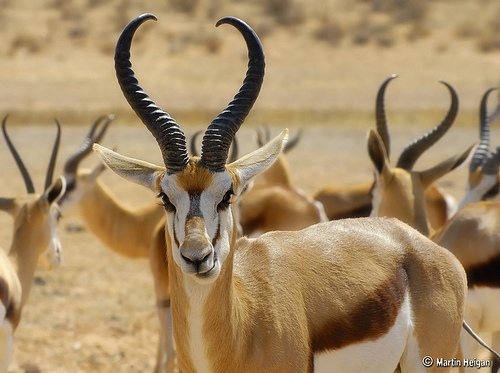<image>
Is the gazelle on the desert? Yes. Looking at the image, I can see the gazelle is positioned on top of the desert, with the desert providing support. 